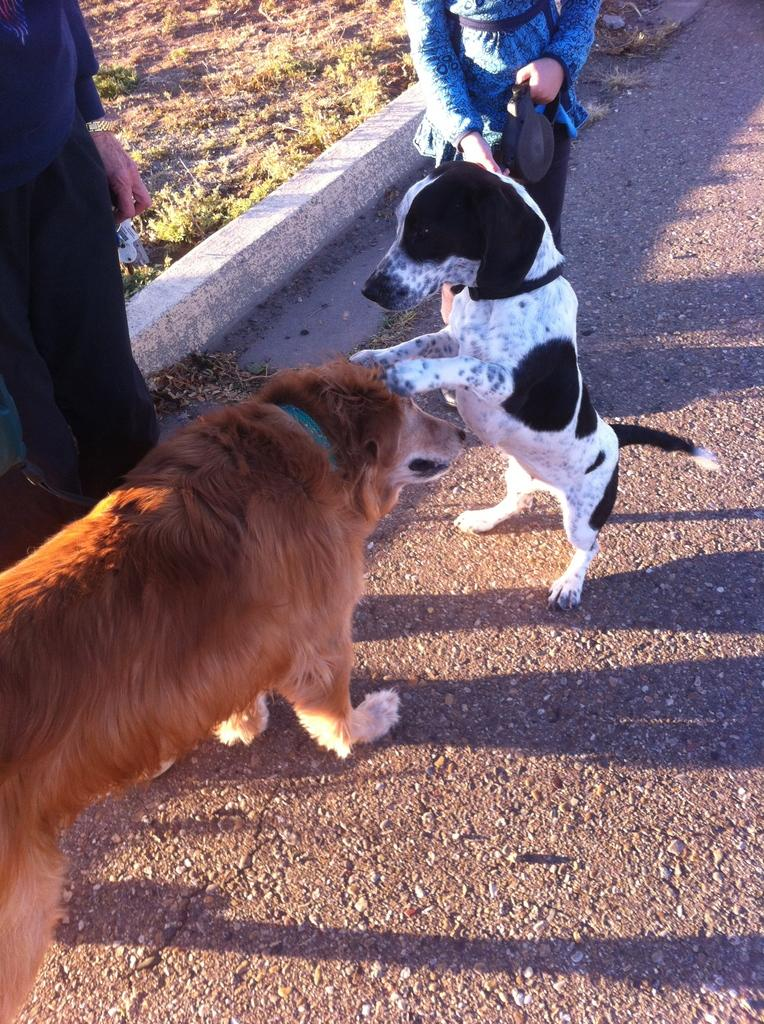How many dogs are in the image? There are two dogs in the image. What else can be seen on the road in the image? There are people on the road in the image. What type of vegetation is visible on the side of the road? There is grass visible on the side of the road. What type of leaf is being played by the band in the image? There is no band present in the image, so it is not possible to determine what type of leaf they might be playing. 